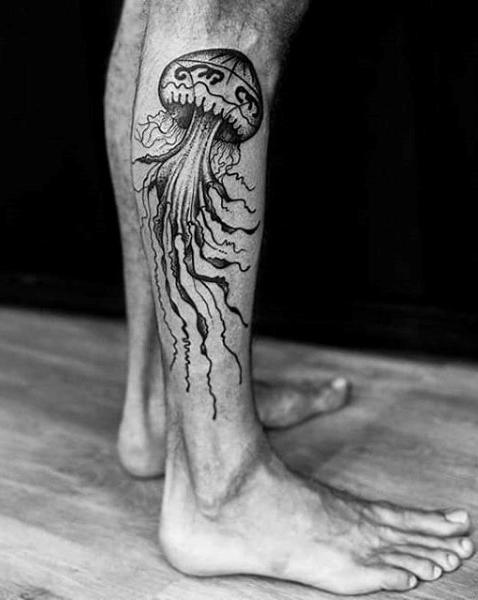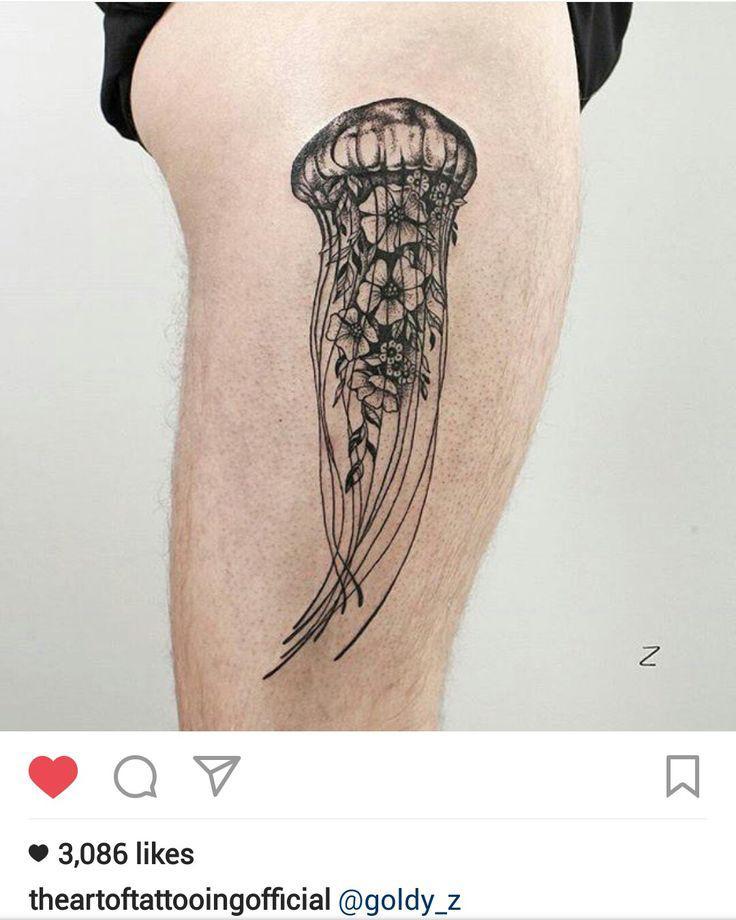The first image is the image on the left, the second image is the image on the right. For the images displayed, is the sentence "Each image shows exactly one tattoo on a person's bare skin, each image an elaborate jelly fish design with long tendrils inked in black." factually correct? Answer yes or no. Yes. The first image is the image on the left, the second image is the image on the right. Considering the images on both sides, is "Right and left images show a non-color tattoo of a single large jellyfish with trailing tentacles on a human leg." valid? Answer yes or no. Yes. 